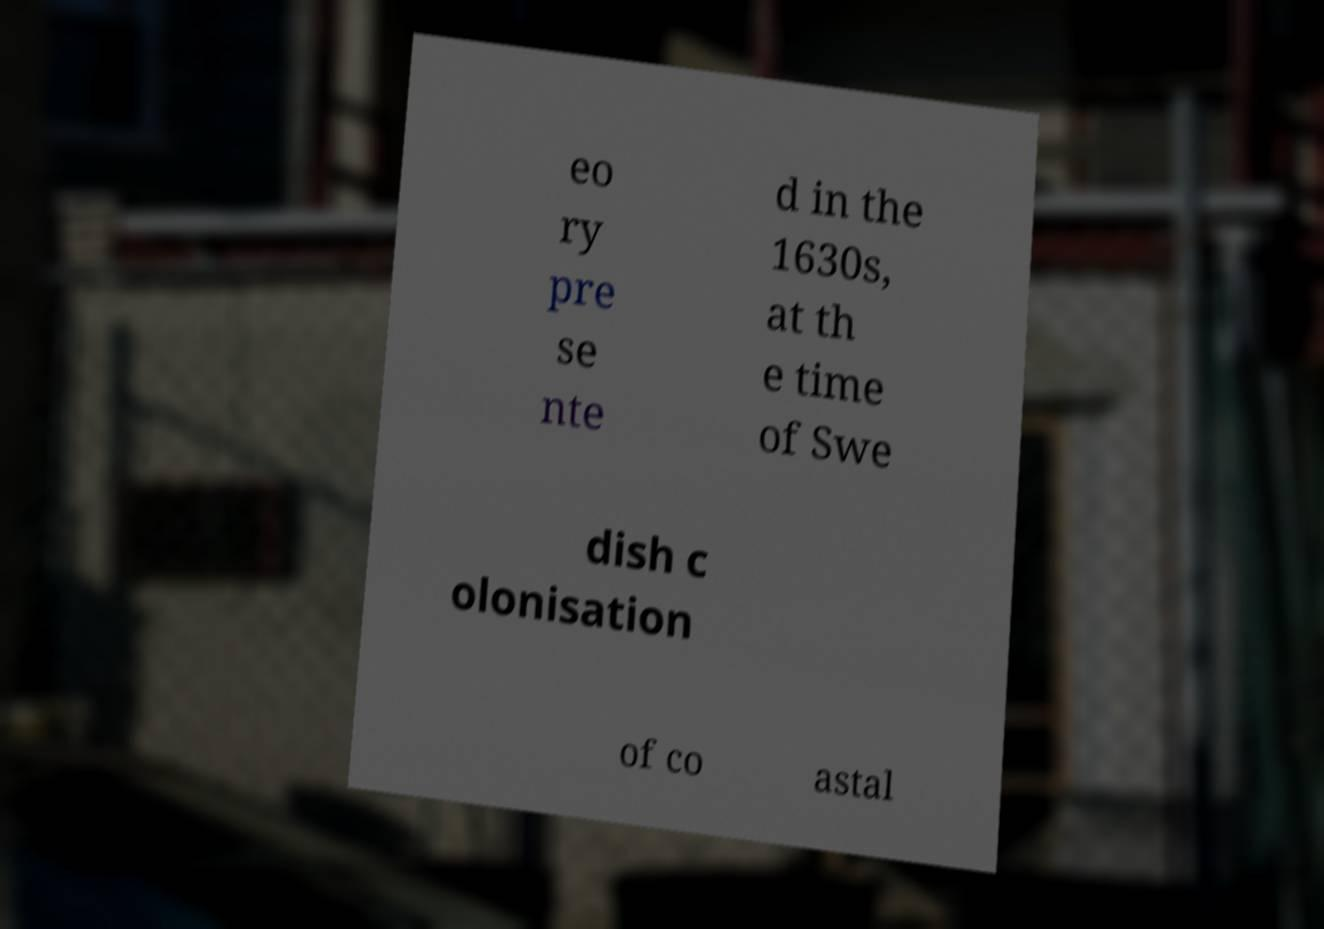Please read and relay the text visible in this image. What does it say? eo ry pre se nte d in the 1630s, at th e time of Swe dish c olonisation of co astal 